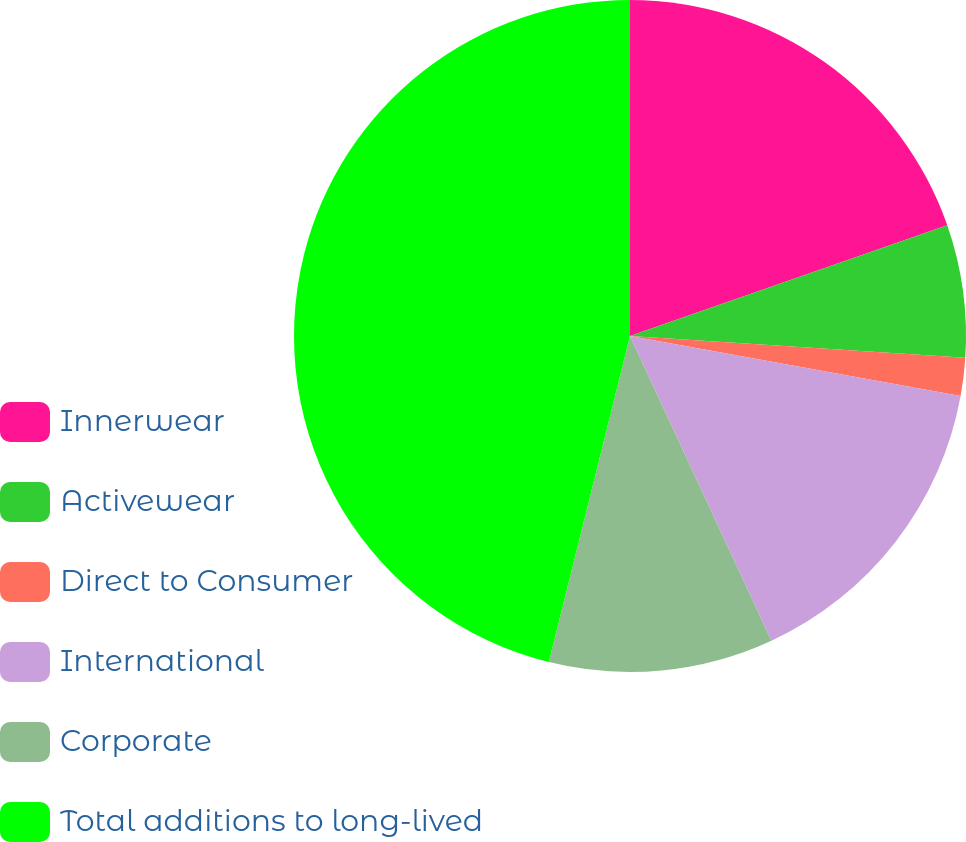Convert chart to OTSL. <chart><loc_0><loc_0><loc_500><loc_500><pie_chart><fcel>Innerwear<fcel>Activewear<fcel>Direct to Consumer<fcel>International<fcel>Corporate<fcel>Total additions to long-lived<nl><fcel>19.66%<fcel>6.37%<fcel>1.83%<fcel>15.23%<fcel>10.8%<fcel>46.12%<nl></chart> 